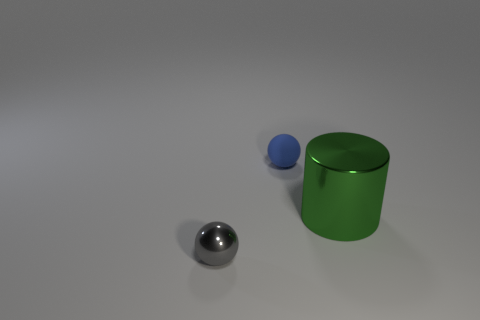Add 3 tiny gray spheres. How many objects exist? 6 Subtract all cylinders. How many objects are left? 2 Subtract 0 red cubes. How many objects are left? 3 Subtract all green metallic cylinders. Subtract all shiny balls. How many objects are left? 1 Add 3 blue matte objects. How many blue matte objects are left? 4 Add 3 small yellow spheres. How many small yellow spheres exist? 3 